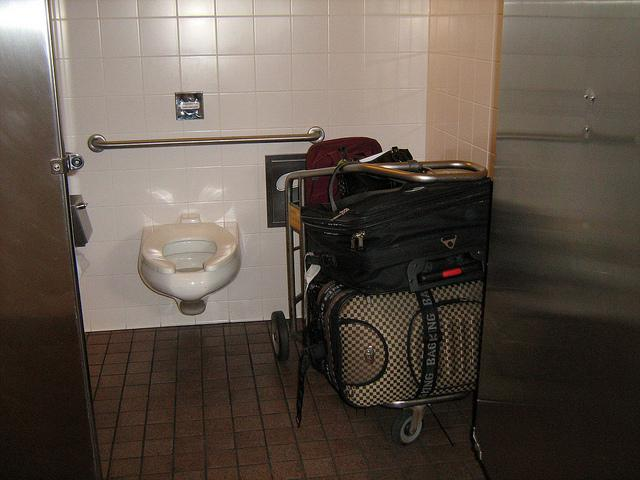Where is this bathroom likely to be found in?

Choices:
A) airport
B) shopping mall
C) school
D) theater airport 